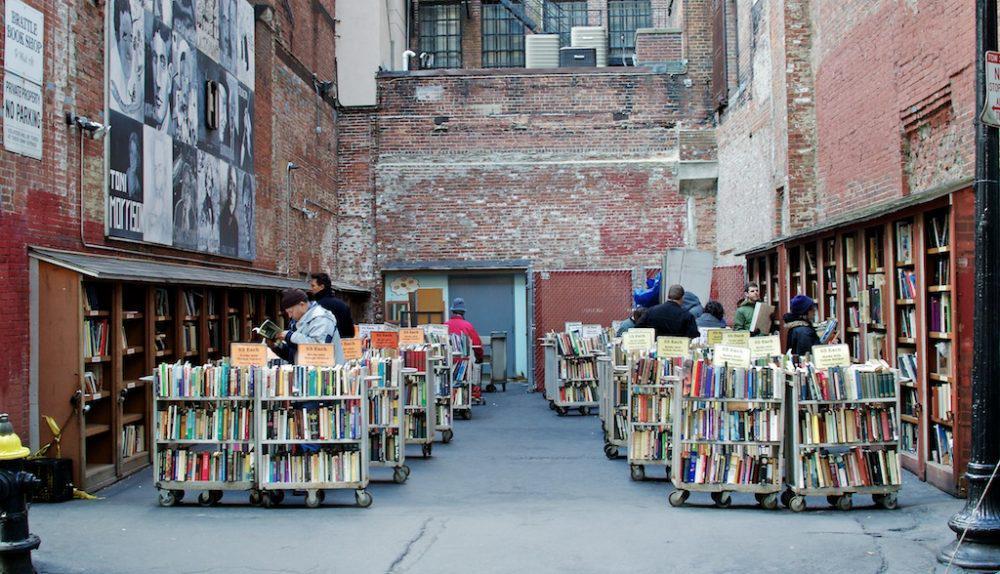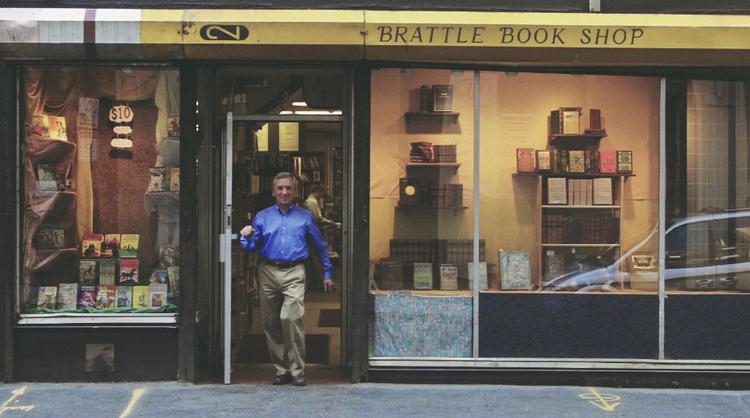The first image is the image on the left, the second image is the image on the right. For the images displayed, is the sentence "A man in tan pants is standing up near a building in the image on the right." factually correct? Answer yes or no. Yes. The first image is the image on the left, the second image is the image on the right. Assess this claim about the two images: "An image shows a yellow sharpened pencil shape above shop windows and below a projecting reddish sign.". Correct or not? Answer yes or no. No. 